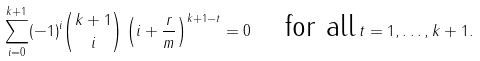Convert formula to latex. <formula><loc_0><loc_0><loc_500><loc_500>\sum _ { i = 0 } ^ { k + 1 } ( - 1 ) ^ { i } \binom { k + 1 } { i } \left ( i + \frac { r } { m } \right ) ^ { k + 1 - t } = 0 \, \quad \text {for all} \, t = 1 , \dots , k + 1 .</formula> 